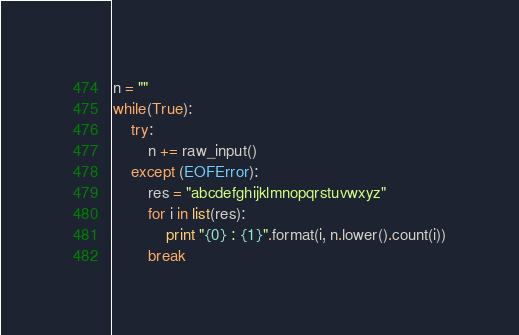Convert code to text. <code><loc_0><loc_0><loc_500><loc_500><_Python_>n = ""
while(True):
    try:
        n += raw_input()
    except (EOFError):
        res = "abcdefghijklmnopqrstuvwxyz"
        for i in list(res):
            print "{0} : {1}".format(i, n.lower().count(i))
        break</code> 